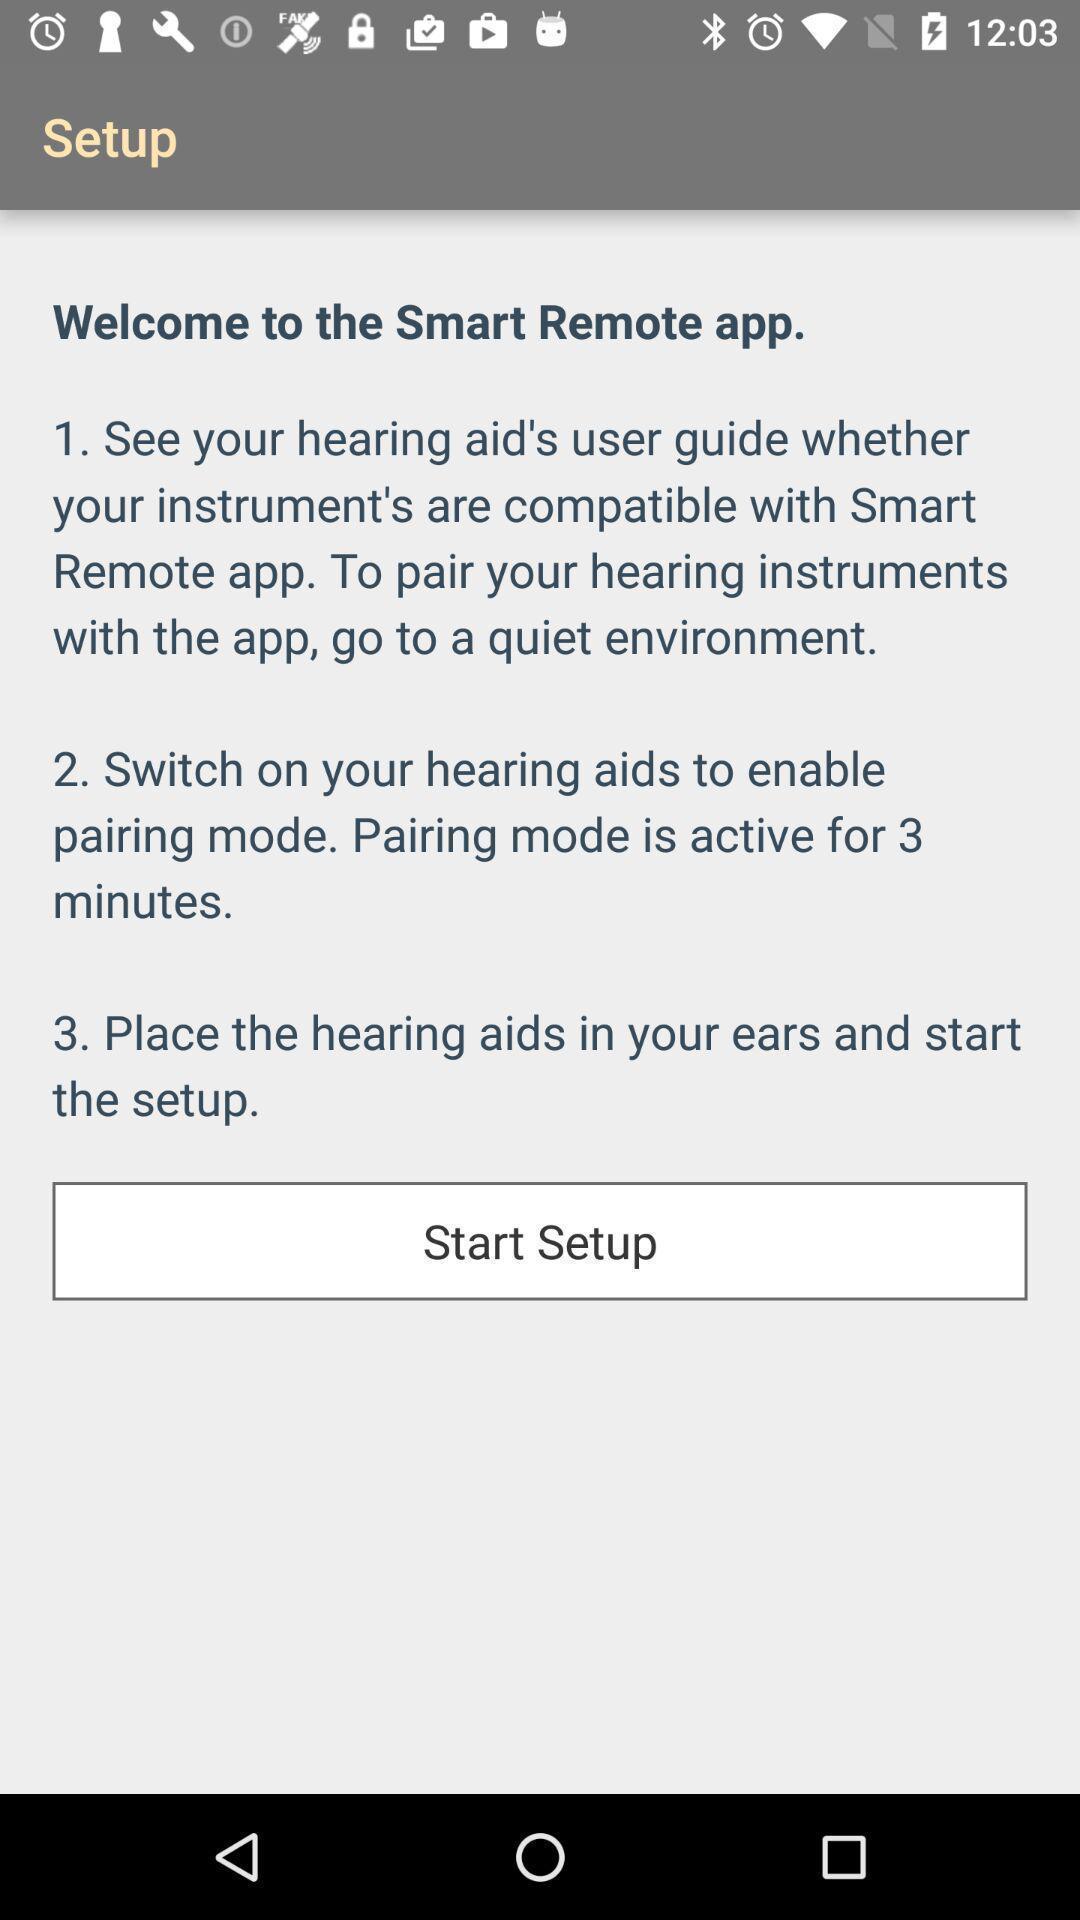What is the overall content of this screenshot? Welcome page of remote control app. 